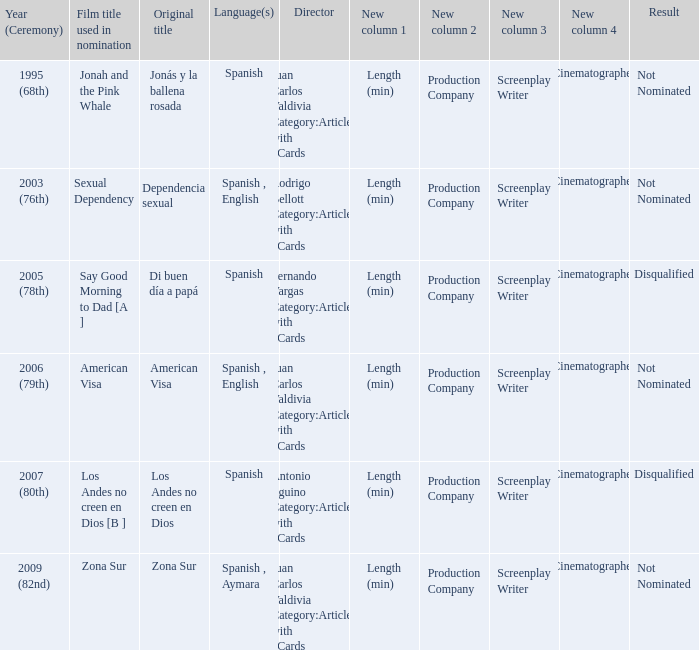What year was Zona Sur nominated? 2009 (82nd). 